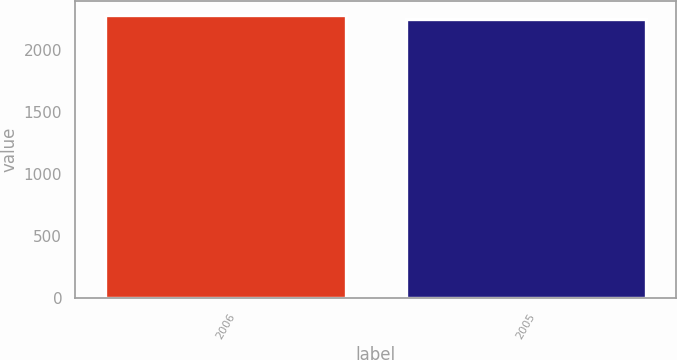Convert chart. <chart><loc_0><loc_0><loc_500><loc_500><bar_chart><fcel>2006<fcel>2005<nl><fcel>2288.1<fcel>2250.4<nl></chart> 